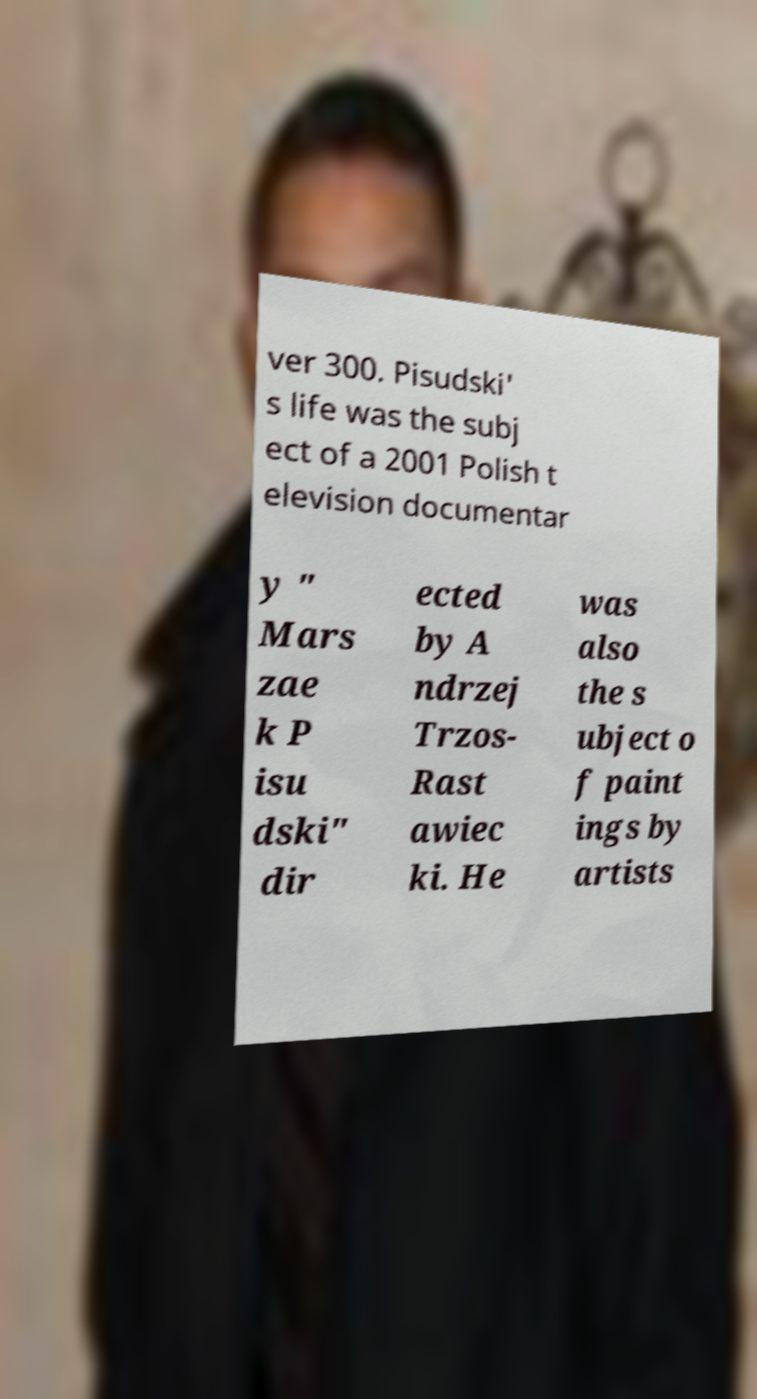For documentation purposes, I need the text within this image transcribed. Could you provide that? ver 300. Pisudski' s life was the subj ect of a 2001 Polish t elevision documentar y " Mars zae k P isu dski" dir ected by A ndrzej Trzos- Rast awiec ki. He was also the s ubject o f paint ings by artists 